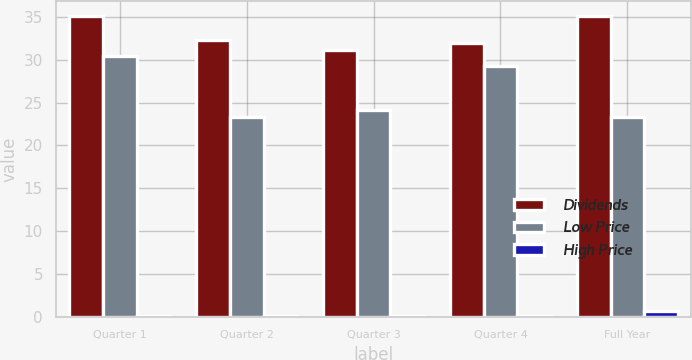<chart> <loc_0><loc_0><loc_500><loc_500><stacked_bar_chart><ecel><fcel>Quarter 1<fcel>Quarter 2<fcel>Quarter 3<fcel>Quarter 4<fcel>Full Year<nl><fcel>Dividends<fcel>35.06<fcel>32.23<fcel>31.09<fcel>31.93<fcel>35.06<nl><fcel>Low Price<fcel>30.47<fcel>23.32<fcel>24.09<fcel>29.3<fcel>23.32<nl><fcel>High Price<fcel>0.17<fcel>0.17<fcel>0.17<fcel>0.17<fcel>0.68<nl></chart> 